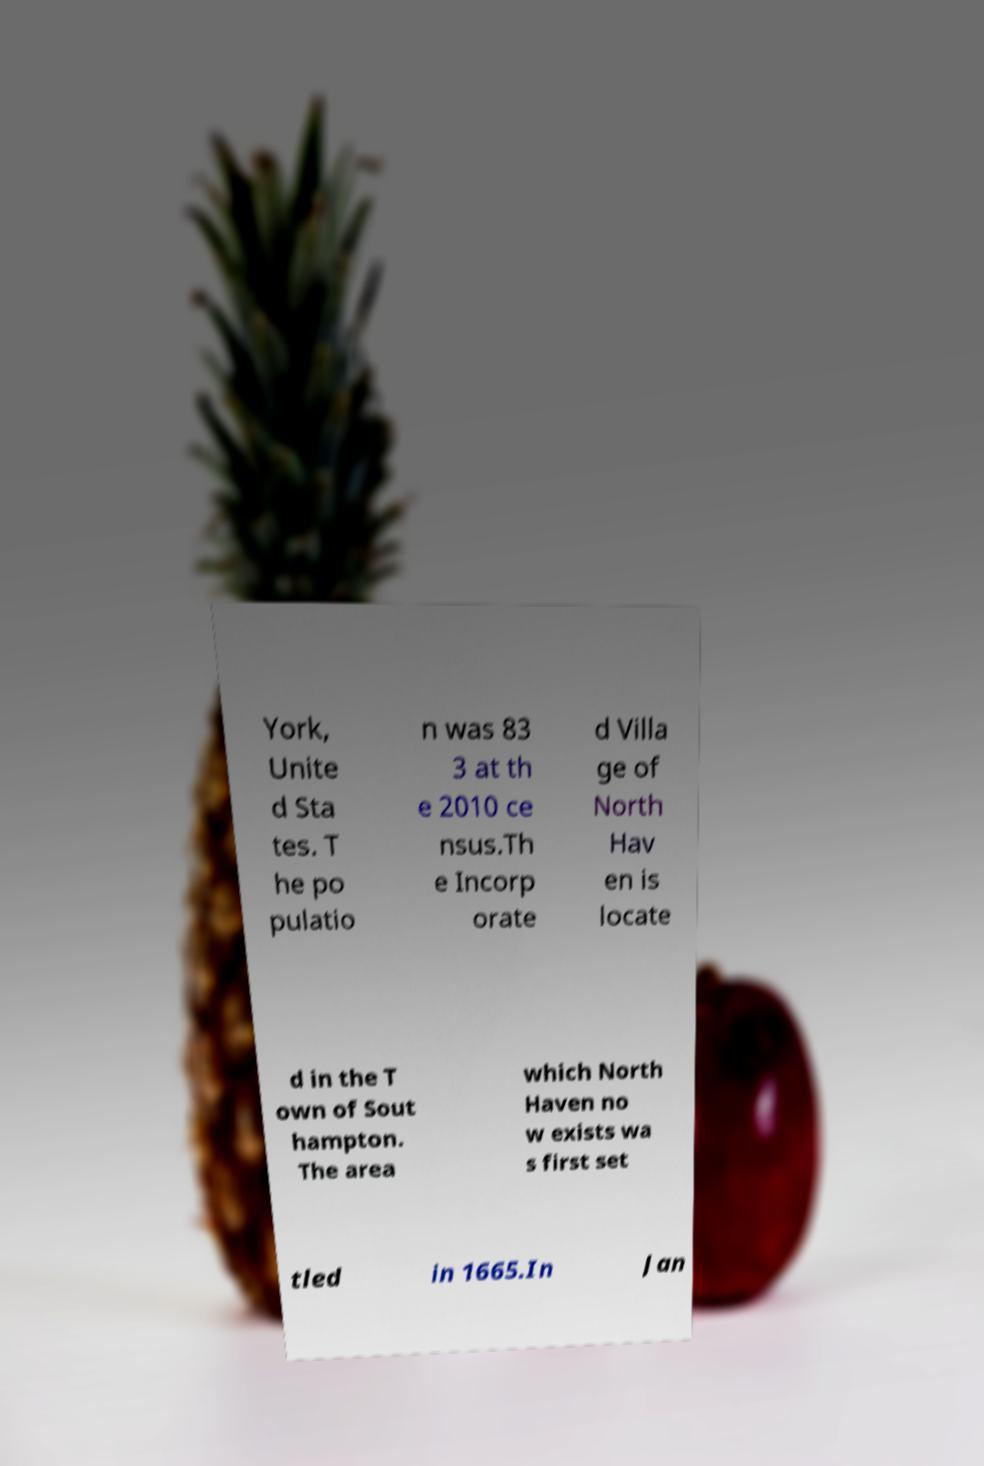Could you extract and type out the text from this image? York, Unite d Sta tes. T he po pulatio n was 83 3 at th e 2010 ce nsus.Th e Incorp orate d Villa ge of North Hav en is locate d in the T own of Sout hampton. The area which North Haven no w exists wa s first set tled in 1665.In Jan 